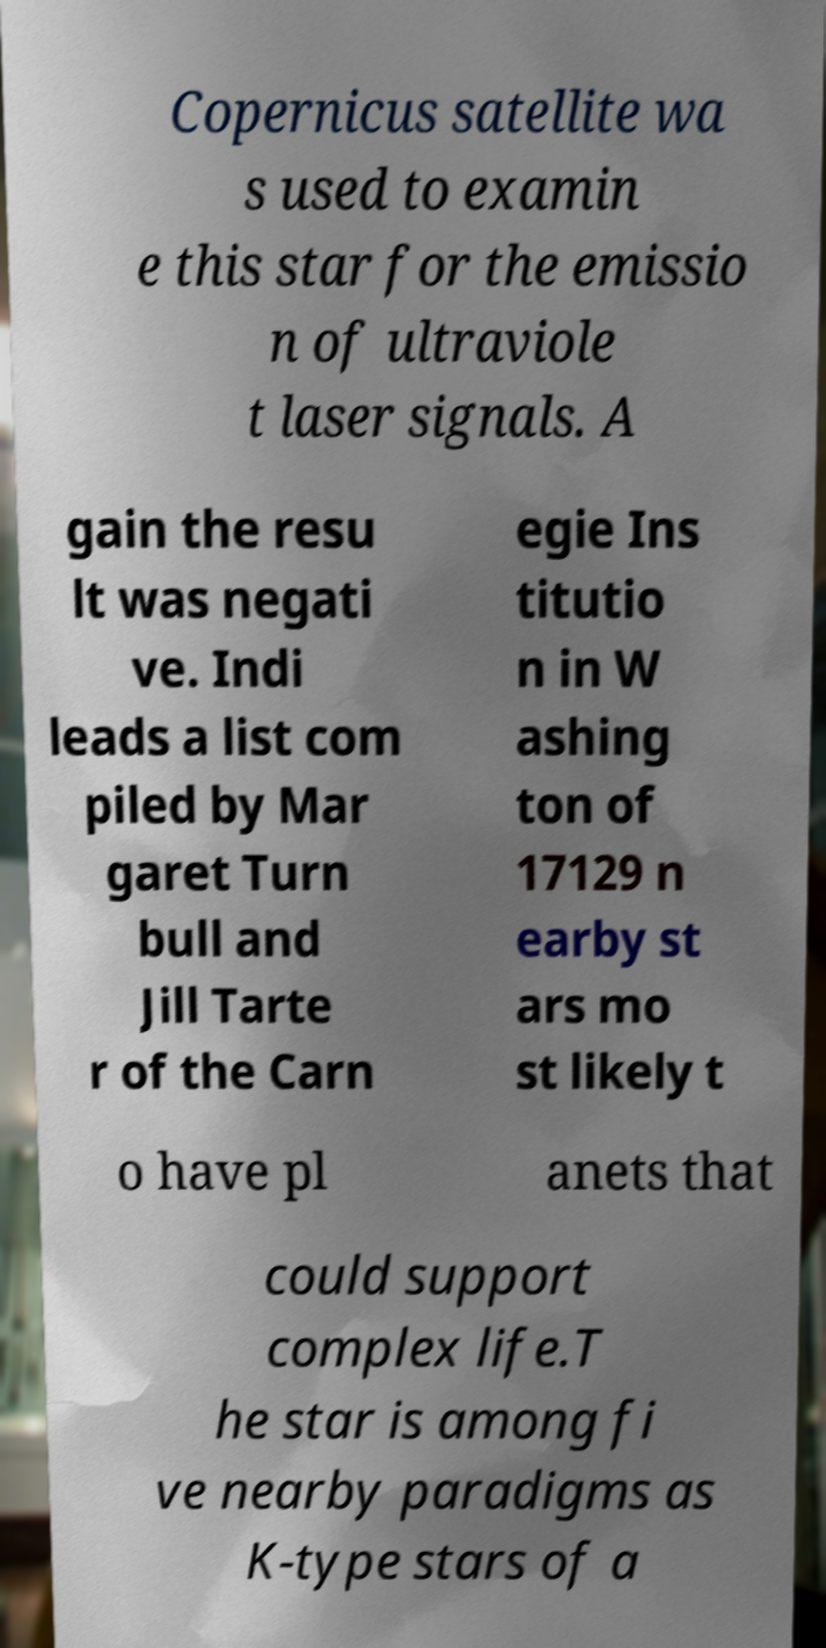There's text embedded in this image that I need extracted. Can you transcribe it verbatim? Copernicus satellite wa s used to examin e this star for the emissio n of ultraviole t laser signals. A gain the resu lt was negati ve. Indi leads a list com piled by Mar garet Turn bull and Jill Tarte r of the Carn egie Ins titutio n in W ashing ton of 17129 n earby st ars mo st likely t o have pl anets that could support complex life.T he star is among fi ve nearby paradigms as K-type stars of a 